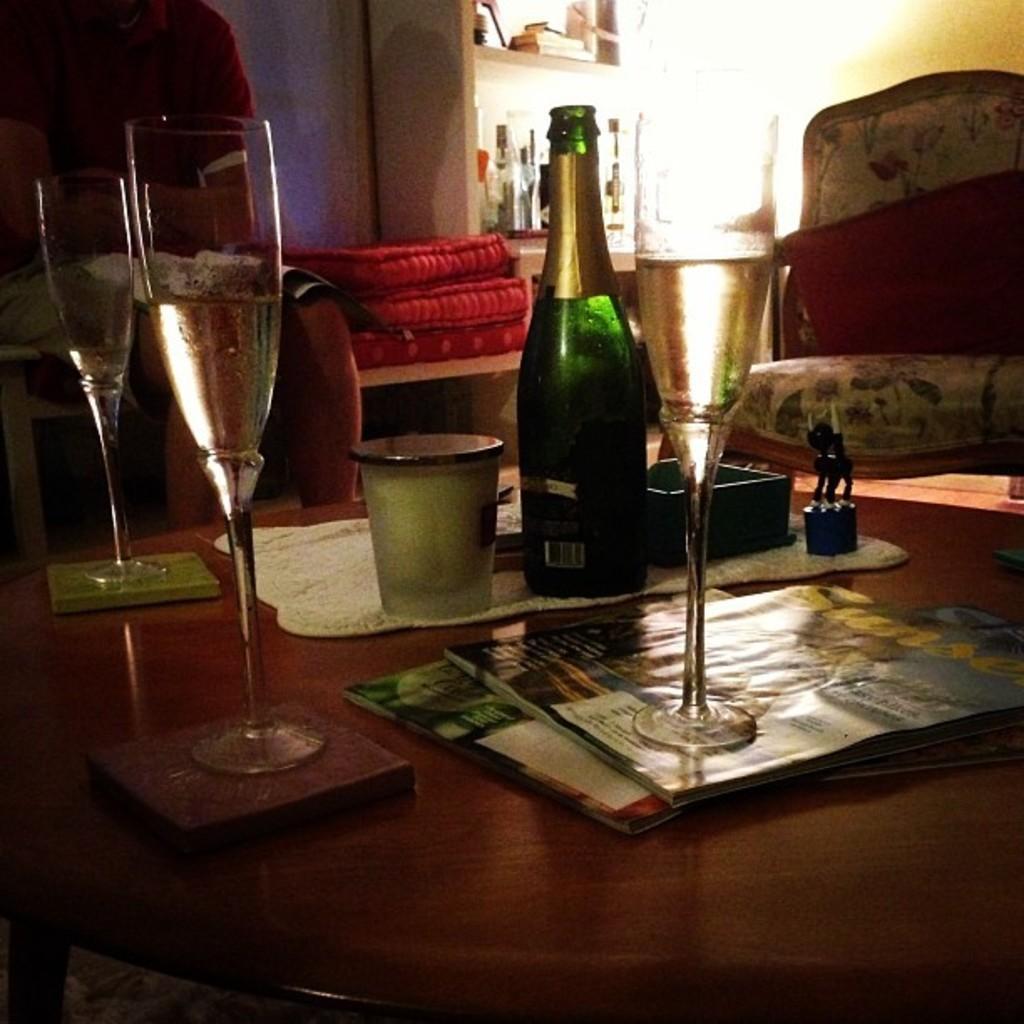Can you describe this image briefly? This picture is of inside the room. In the foreground there is a table on the top of which glasses of drink, bottle, books and some other items are placed. On the right there is a chair. In the background we can see a wall, table and the cabinet containing books. 